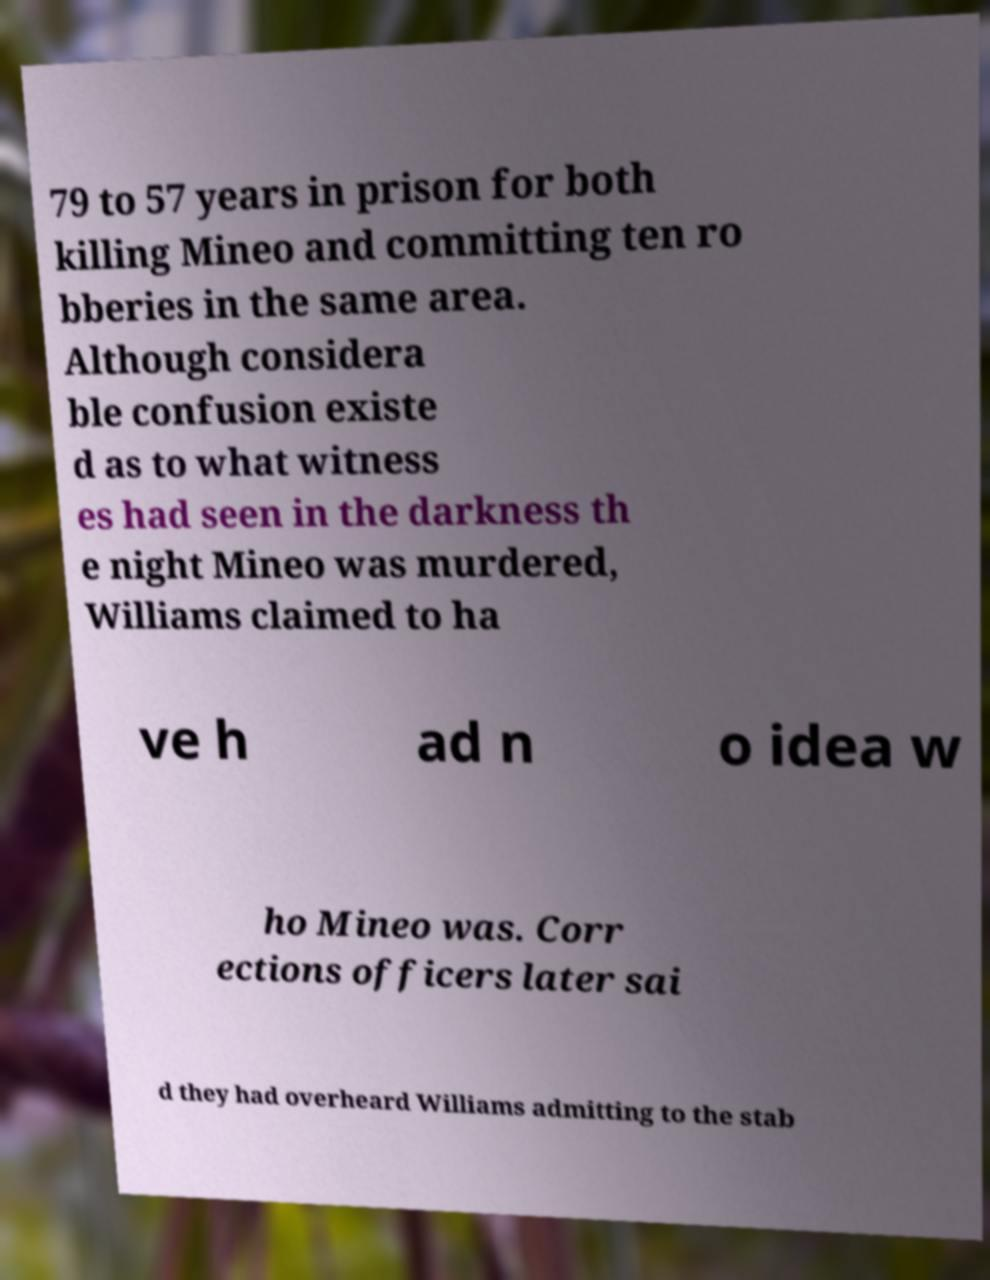Could you assist in decoding the text presented in this image and type it out clearly? 79 to 57 years in prison for both killing Mineo and committing ten ro bberies in the same area. Although considera ble confusion existe d as to what witness es had seen in the darkness th e night Mineo was murdered, Williams claimed to ha ve h ad n o idea w ho Mineo was. Corr ections officers later sai d they had overheard Williams admitting to the stab 